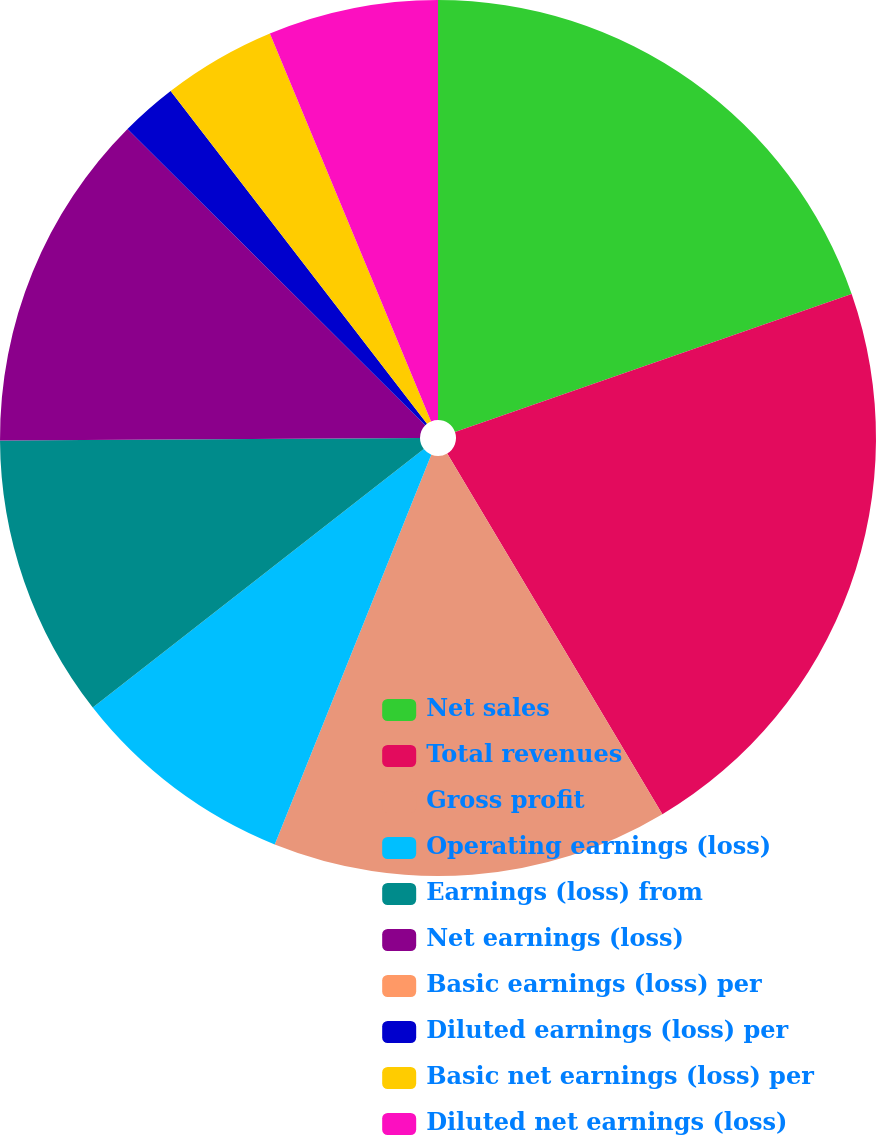Convert chart. <chart><loc_0><loc_0><loc_500><loc_500><pie_chart><fcel>Net sales<fcel>Total revenues<fcel>Gross profit<fcel>Operating earnings (loss)<fcel>Earnings (loss) from<fcel>Net earnings (loss)<fcel>Basic earnings (loss) per<fcel>Diluted earnings (loss) per<fcel>Basic net earnings (loss) per<fcel>Diluted net earnings (loss)<nl><fcel>19.67%<fcel>21.77%<fcel>14.64%<fcel>8.37%<fcel>10.46%<fcel>12.55%<fcel>0.0%<fcel>2.09%<fcel>4.18%<fcel>6.27%<nl></chart> 